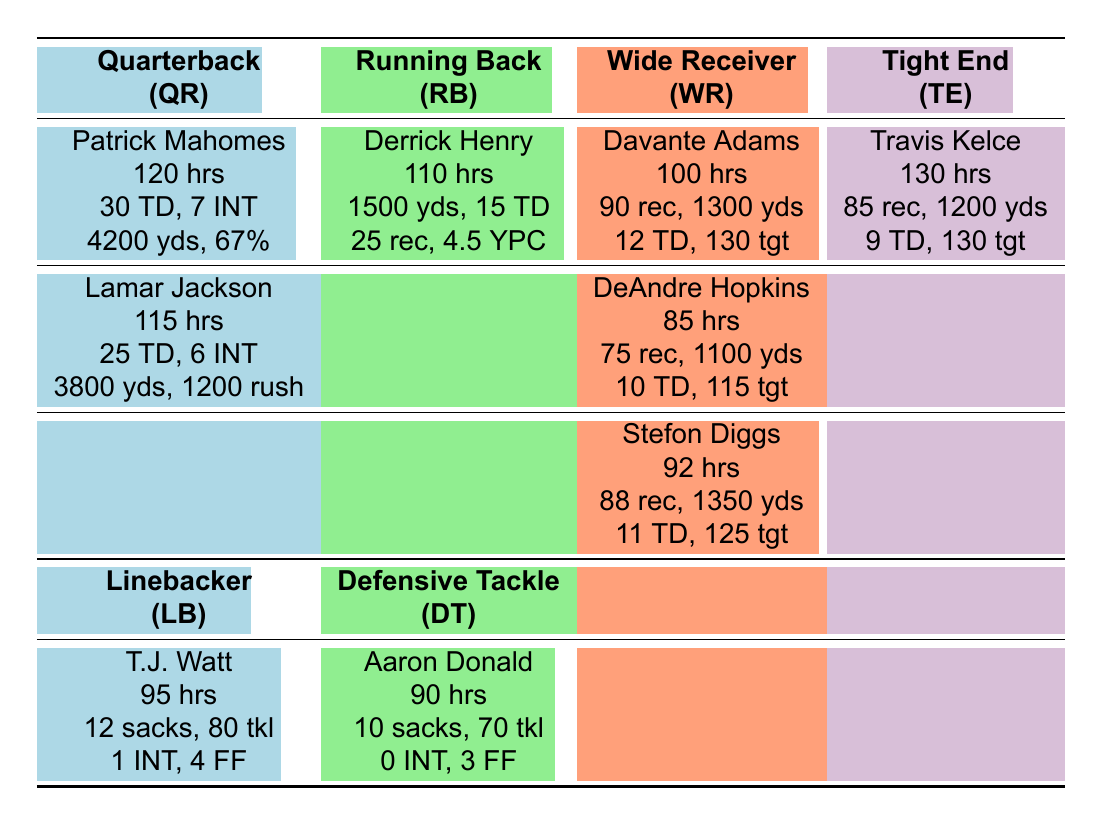What is the highest number of Monthly Training Hours recorded? Patrick Mahomes has the highest number of training hours listed at 120.
Answer: 120 Which quarterback has more Touchdowns, Patrick Mahomes or Lamar Jackson? Patrick Mahomes has 30 Touchdowns, while Lamar Jackson has 25. Thus, Mahomes has more.
Answer: Patrick Mahomes How many Receptions did Stefon Diggs have? Stefon Diggs had 88 Receptions according to the table.
Answer: 88 What is the average Monthly Training Hours of all the players listed? The players' Monthly Training Hours are 120, 110, 100, 95, 85, 130, 90, 115, 92. Adding them gives a total of 1,017 hours and dividing by the 9 players yields an average of 113 hours.
Answer: 113 Did any defensive player record more than 10 Sacks? T.J. Watt recorded 12 Sacks, which is more than 10, confirming the statement is true.
Answer: Yes Which Wide Receiver has the most Receiving Yards? Davante Adams is the wide receiver with 1300 Receiving Yards, while DeAndre Hopkins has 1100 and Stefon Diggs has 1350, which is the highest.
Answer: Stefon Diggs How many total Touchdowns were scored by the players listed? The total number of Touchdowns is derived from adding 30 (Mahomes) + 15 (Henry) + 12 (Adams) + 9 (Kelce) + 10 (Hopkins) + 11 (Diggs) + 25 (Jackson), which sums to 112 Touchdowns.
Answer: 112 Is there any player who had a Monthly Training Hour count less than 90? The data shows that DeAndre Hopkins has 85 Monthly Training Hours, which confirms there is a player with less than 90 hours.
Answer: Yes Who has more Rushing Yards, Derrick Henry or Lamar Jackson? Derrick Henry has 1500 Rushing Yards, whereas Lamar Jackson has 1200 Rushing Yards, making Henry the winner in this comparison.
Answer: Derrick Henry 